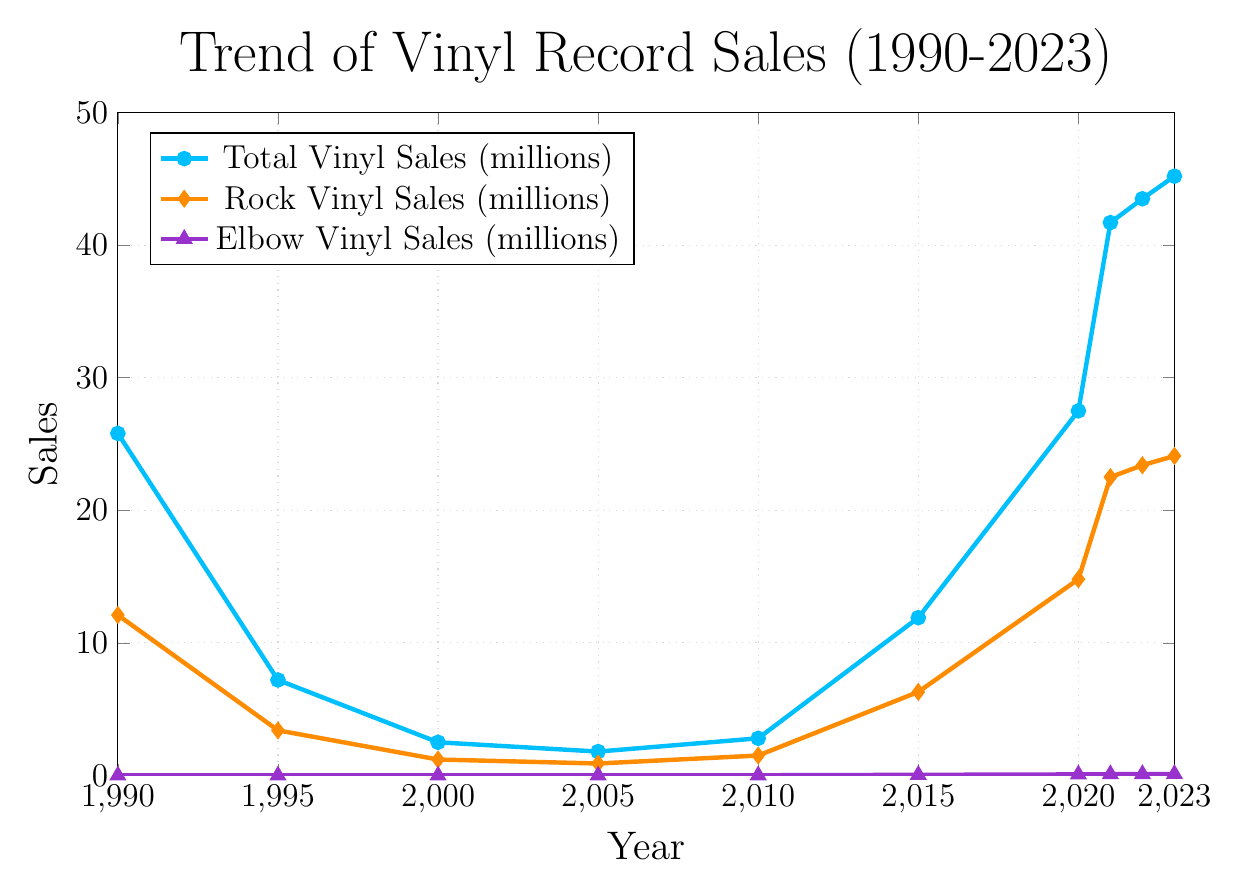What's the highest total vinyl sales value? Look at the blue line in the chart and identify the highest point. The highest total sales value occurs in 2023 with 45.2 million sales.
Answer: 45.2 million How much did rock vinyl sales increase from 2000 to 2023? Check the orange line for rock vinyl sales in 2000 and 2023. The sales in 2000 were 1.2 million, and in 2023 they were 24.1 million. Subtract the 2000 value from the 2023 value: 24.1 - 1.2 = 22.9 million.
Answer: 22.9 million In which year did Elbow's vinyl sales first appear on the chart? Look at the purple line, which represents Elbow's vinyl sales, and identify the first year it appears above zero. The first appearance is in 2005 with 0.003 million (3 thousand) sales.
Answer: 2005 What was the difference in total vinyl sales between 1990 and 1995? Look at the blue line and find the total sales for 1990 and 1995. In 1990, the sales were 25.8 million and in 1995, they were 7.2 million. Calculate the difference: 25.8 - 7.2 = 18.6 million.
Answer: 18.6 million By how much did Elbow's vinyl sales increase from 2015 to 2023? Find the values for Elbow's vinyl sales in 2015 and 2023 on the purple line. In 2015, sales were 0.045 million (45 thousand), and in 2023, they were 0.110 million (110 thousand). Calculate the difference: 0.110 - 0.045 = 0.065 million (or 110,000 - 45,000 = 65,000).
Answer: 65 thousand Which year had the lowest rock vinyl sales, and what was the value? Identify the lowest point on the orange line. The lowest rock vinyl sales was in 2005 with 0.9 million sales.
Answer: 2005, 0.9 million How does the trend of total vinyl sales compare to rock vinyl sales from 1990 to 2023? Observe both the blue and orange lines. Both lines show a significant decline from 1990 until around 2005, then a steady increase from 2010 through 2023.
Answer: Similar declining and rising trend What is the average annual increase in total vinyl sales from 2010 to 2023? Identify the total vinyl sales values for 2010 and 2023: 2.8 million in 2010 and 45.2 million in 2023. Calculate the total increase: 45.2 - 2.8 = 42.4 million. Divide this by the number of years: (42.4 / 13) ≈ 3.26 million per year.
Answer: 3.26 million per year Compare the total increase in rock vinyl sales with the increase in total vinyl sales between 2015 and 2023. Identify the sales values for both categories for 2015 and 2023. For rock, 6.3 million (2015) to 24.1 million (2023), an increase of 24.1 - 6.3 = 17.8 million. For total vinyl, 11.9 million (2015) to 45.2 million (2023), an increase of 45.2 - 11.9 = 33.3 million. Compare the two increases, 33.3 million for total sales vs. 17.8 million for rock sales.
Answer: 33.3 million (total) vs. 17.8 million (rock) Which category shows the most consistent upward trend from 2005 to 2023? Examine the trends of all lines from 2005 to 2023. The purple line representing Elbow vinyl sales shows the most consistent upward trend without any dips, continuously increasing every year.
Answer: Elbow vinyl sales 